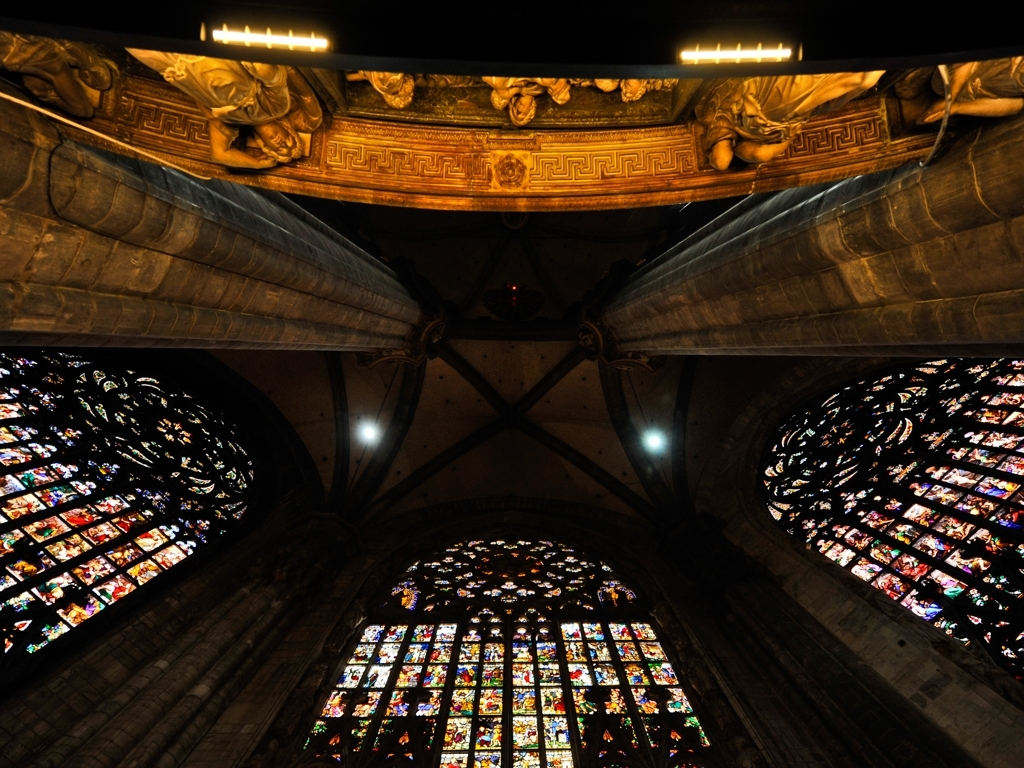What does the presence of stained glass windows suggest about the building's use? Stained glass windows are often found in places of worship and are used to tell stories or represent biblical figures through their imagery. The abundance and elaborate design of these windows suggest that the building is likely a church or cathedral, intended for religious services and to inspire awe. 